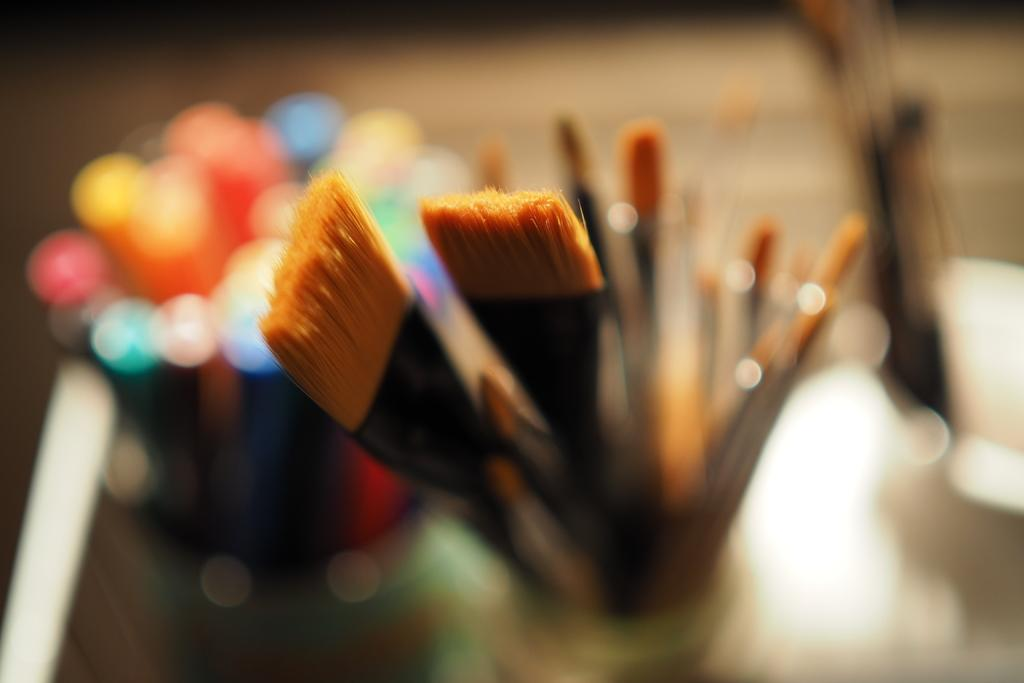What objects are in the center of the image? There are paint brushes in the center of the image. What can be found on the left side of the image? There are colors on the left side of the image. What type of train can be seen in the image? There is no train present in the image; it features paint brushes and colors. How does the quietness of the image contribute to the overall atmosphere? The image does not convey any specific level of quietness or atmosphere, as it only shows paint brushes and colors. 